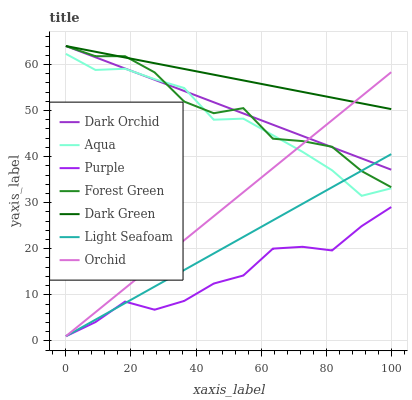Does Purple have the minimum area under the curve?
Answer yes or no. Yes. Does Dark Green have the maximum area under the curve?
Answer yes or no. Yes. Does Aqua have the minimum area under the curve?
Answer yes or no. No. Does Aqua have the maximum area under the curve?
Answer yes or no. No. Is Light Seafoam the smoothest?
Answer yes or no. Yes. Is Forest Green the roughest?
Answer yes or no. Yes. Is Purple the smoothest?
Answer yes or no. No. Is Purple the roughest?
Answer yes or no. No. Does Orchid have the lowest value?
Answer yes or no. Yes. Does Aqua have the lowest value?
Answer yes or no. No. Does Dark Green have the highest value?
Answer yes or no. Yes. Does Aqua have the highest value?
Answer yes or no. No. Is Purple less than Dark Green?
Answer yes or no. Yes. Is Aqua greater than Purple?
Answer yes or no. Yes. Does Forest Green intersect Aqua?
Answer yes or no. Yes. Is Forest Green less than Aqua?
Answer yes or no. No. Is Forest Green greater than Aqua?
Answer yes or no. No. Does Purple intersect Dark Green?
Answer yes or no. No. 